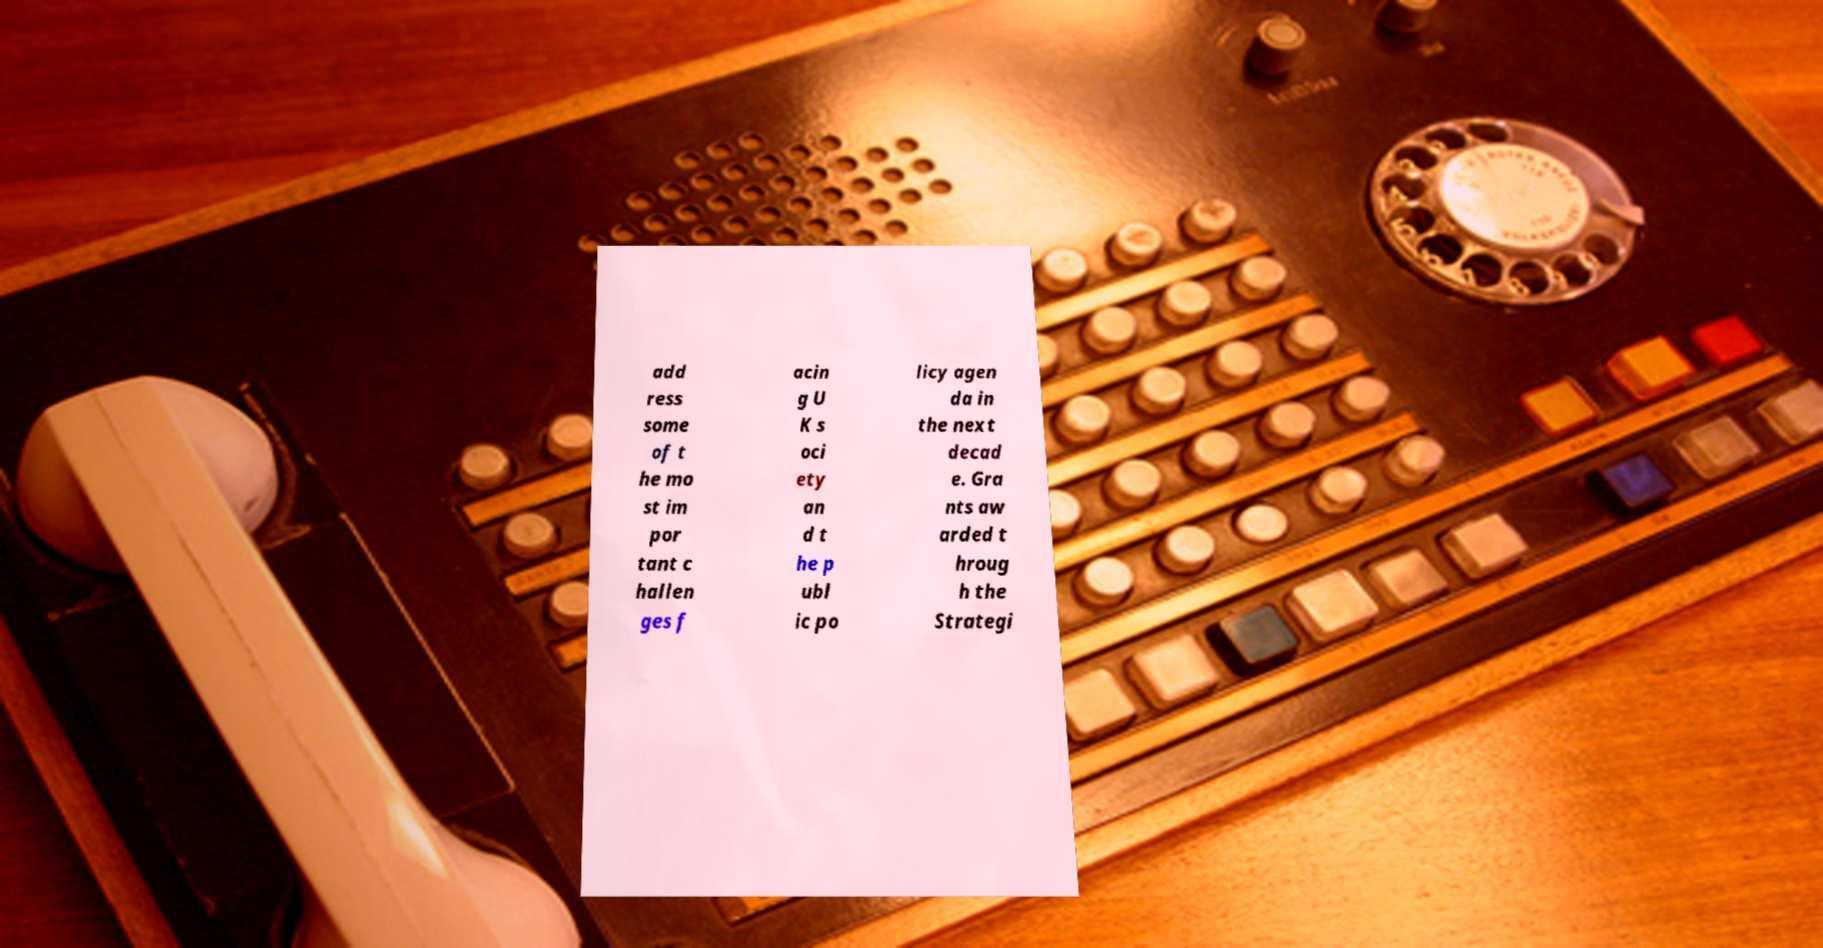For documentation purposes, I need the text within this image transcribed. Could you provide that? add ress some of t he mo st im por tant c hallen ges f acin g U K s oci ety an d t he p ubl ic po licy agen da in the next decad e. Gra nts aw arded t hroug h the Strategi 